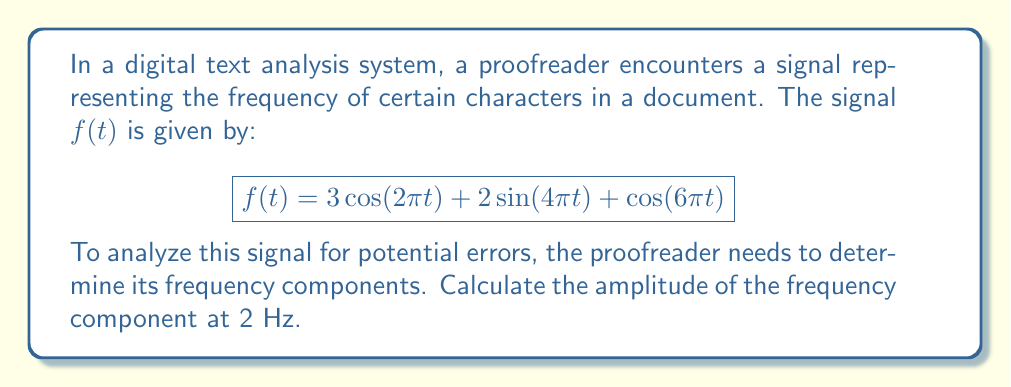Give your solution to this math problem. To solve this problem, we need to follow these steps:

1) First, recall that the Fourier transform helps us identify the frequency components of a signal. In this case, we're given the signal in the time domain and need to analyze its frequency components.

2) The given signal is already expressed as a sum of sinusoids, which makes our job easier. Each term represents a different frequency component:

   $$3\cos(2\pi t)$$ represents a component at 1 Hz
   $$2\sin(4\pi t)$$ represents a component at 2 Hz
   $$\cos(6\pi t)$$ represents a component at 3 Hz

3) We're asked about the component at 2 Hz, which corresponds to the term $2\sin(4\pi t)$.

4) In general, a sinusoidal term $A\sin(2\pi ft)$ or $A\cos(2\pi ft)$ represents a frequency component at $f$ Hz with amplitude $A$.

5) Therefore, the amplitude of the 2 Hz component is 2.

Note: In a more complex scenario, we might need to use the Discrete Fourier Transform (DFT) or its fast algorithm, the Fast Fourier Transform (FFT), to analyze digitized text. However, in this simplified example, the signal is already given in a form that allows direct identification of its frequency components.
Answer: The amplitude of the frequency component at 2 Hz is 2. 